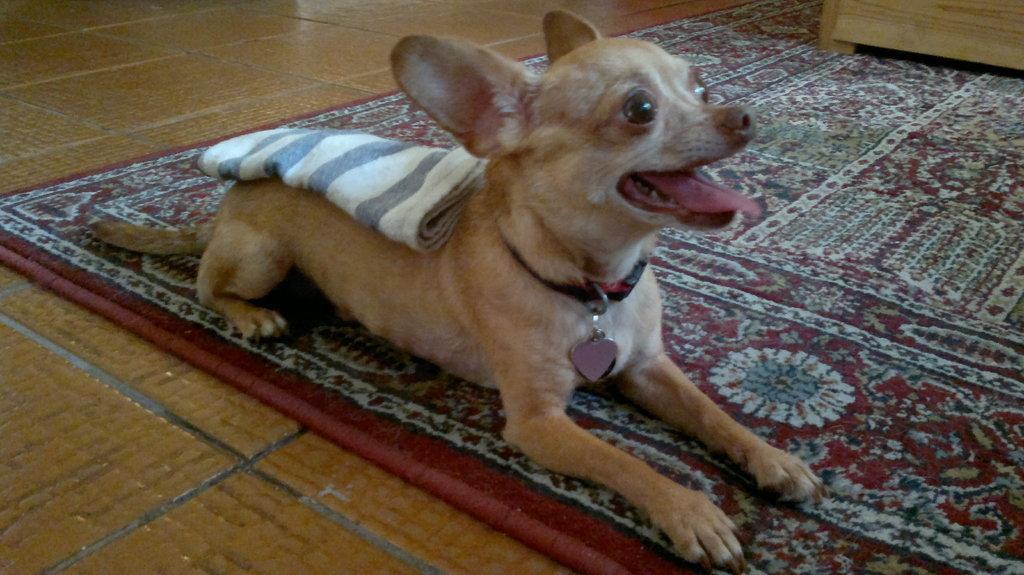Describe this image in one or two sentences. In this picture we can see a cloth on the dog. This dog is sitting on the carpet. We can see a wooden object on top right. 